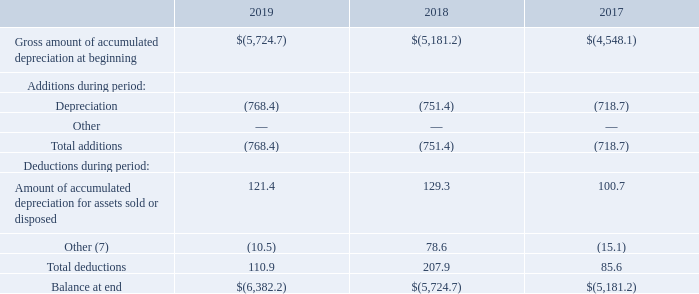AMERICAN TOWER CORPORATION AND SUBSIDIARIES SCHEDULE III—SCHEDULE OF REAL ESTATE AND ACCUMULATED DEPRECIATION (dollars in millions)
(7) Primarily includes foreign currency exchange rate fluctuations and other deductions.
What did the calculation of Other primarily include? Foreign currency exchange rate fluctuations and other deductions. What was the depreciation cost in 2019?
Answer scale should be: million. (768.4). What was the total additions in 2017?
Answer scale should be: million. (718.7). What was the change in depreciation between 2018 and 2019?
Answer scale should be: million. -768.4-(-751.4)
Answer: -17. What was the change in Gross amount of accumulated depreciation at beginning between 2017 and 2018?
Answer scale should be: million. -$5,181.2-(-$4,548.1)
Answer: -633.1. What was the percentage change in total deductions between 2018 and 2019?
Answer scale should be: percent. (110.9-207.9)/207.9
Answer: -46.66. 